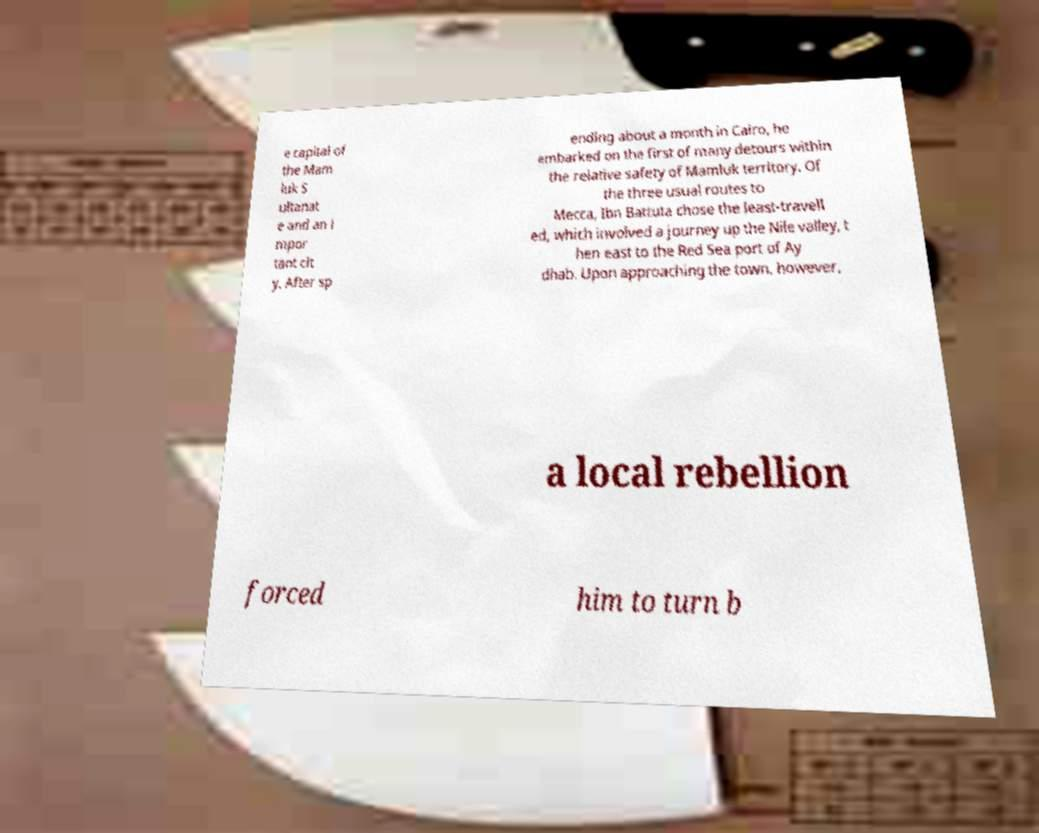Please identify and transcribe the text found in this image. e capital of the Mam luk S ultanat e and an i mpor tant cit y. After sp ending about a month in Cairo, he embarked on the first of many detours within the relative safety of Mamluk territory. Of the three usual routes to Mecca, Ibn Battuta chose the least-travell ed, which involved a journey up the Nile valley, t hen east to the Red Sea port of Ay dhab. Upon approaching the town, however, a local rebellion forced him to turn b 